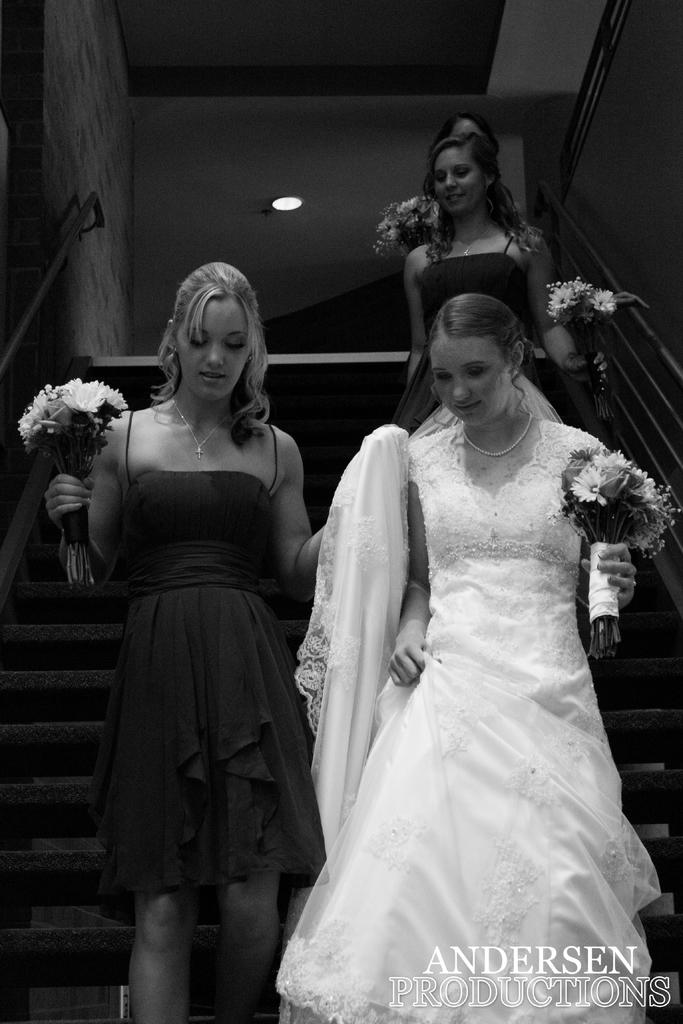What is happening in the image? There are women in the image, and they are on stage. What are the women holding in the image? The women are holding flowers. Can you describe the attire of one of the women? One woman is wearing a white dress. What type of toothpaste is being used by the women on stage? There is no toothpaste present in the image; the women are holding flowers. 